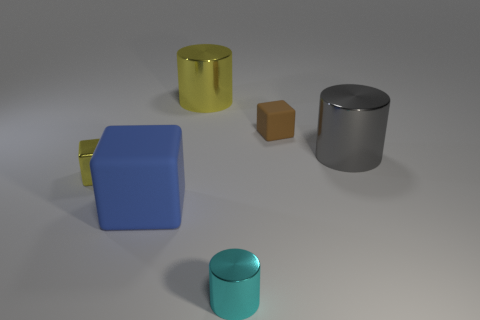Which object stands out the most, and why? The blue cube stands out the most, primarily due to its vibrant color, which contrasts with the relatively muted colors of the other objects. Moreover, the cube has a distinctive yellow handle, adding to its uniqueness in this collection of objects. Additionally, its placement at the forefront of the composition draws the viewer's attention. 